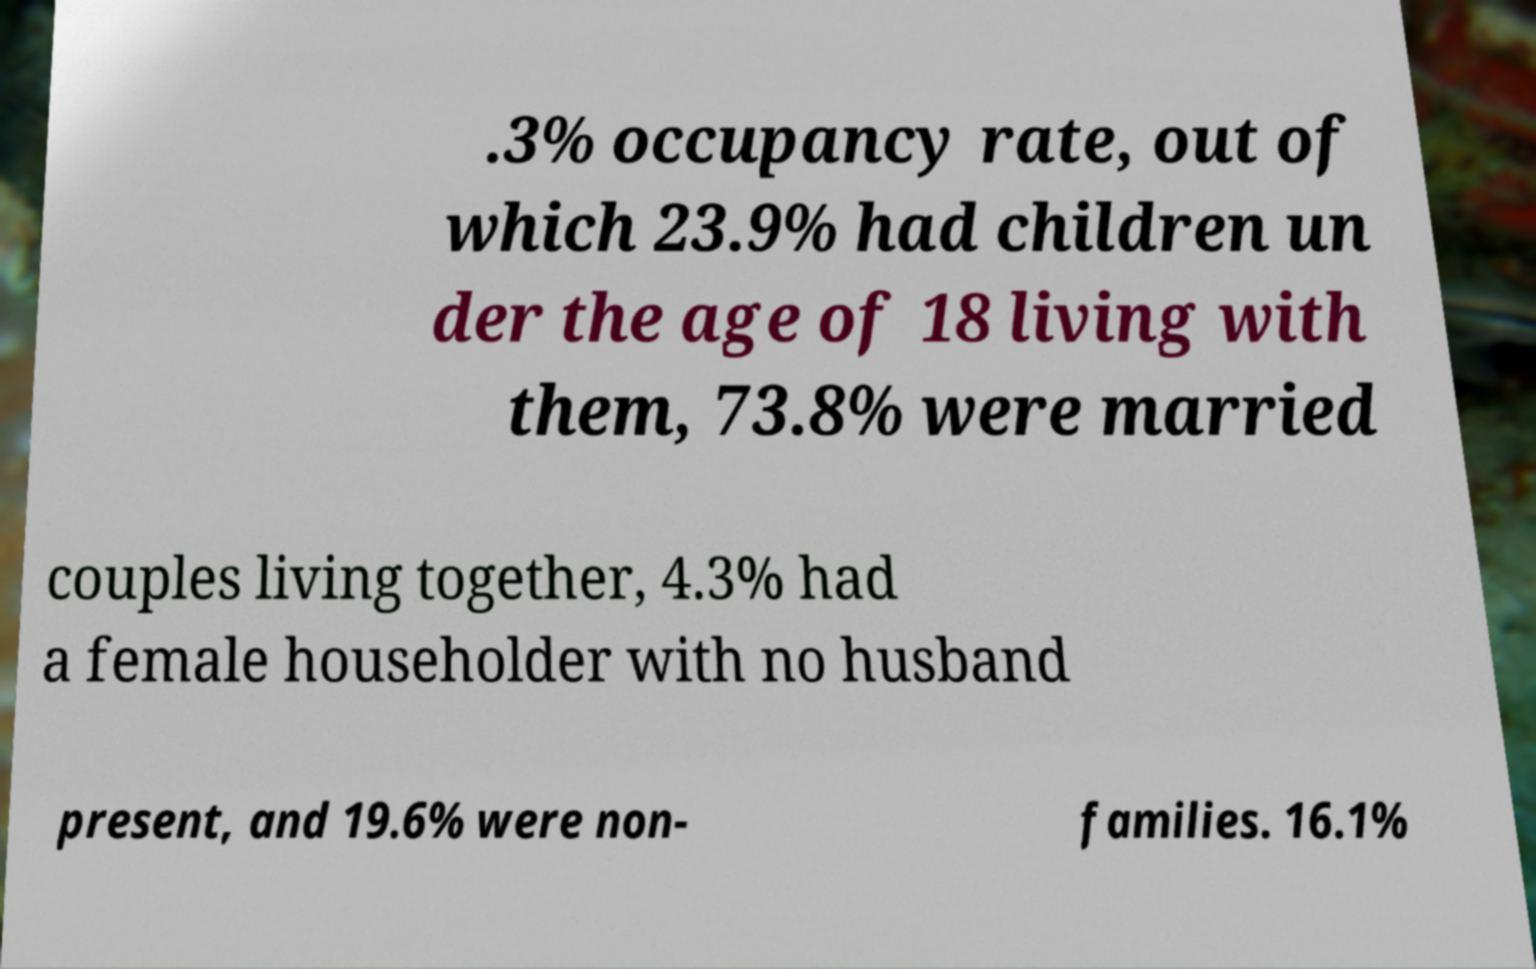What messages or text are displayed in this image? I need them in a readable, typed format. .3% occupancy rate, out of which 23.9% had children un der the age of 18 living with them, 73.8% were married couples living together, 4.3% had a female householder with no husband present, and 19.6% were non- families. 16.1% 